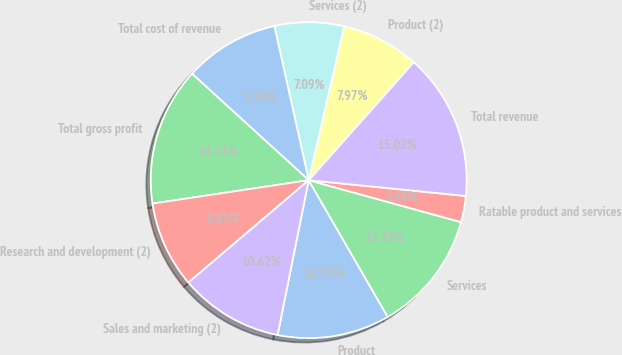Convert chart. <chart><loc_0><loc_0><loc_500><loc_500><pie_chart><fcel>Product<fcel>Services<fcel>Ratable product and services<fcel>Total revenue<fcel>Product (2)<fcel>Services (2)<fcel>Total cost of revenue<fcel>Total gross profit<fcel>Research and development (2)<fcel>Sales and marketing (2)<nl><fcel>11.5%<fcel>12.38%<fcel>2.68%<fcel>15.02%<fcel>7.97%<fcel>7.09%<fcel>9.74%<fcel>14.14%<fcel>8.85%<fcel>10.62%<nl></chart> 